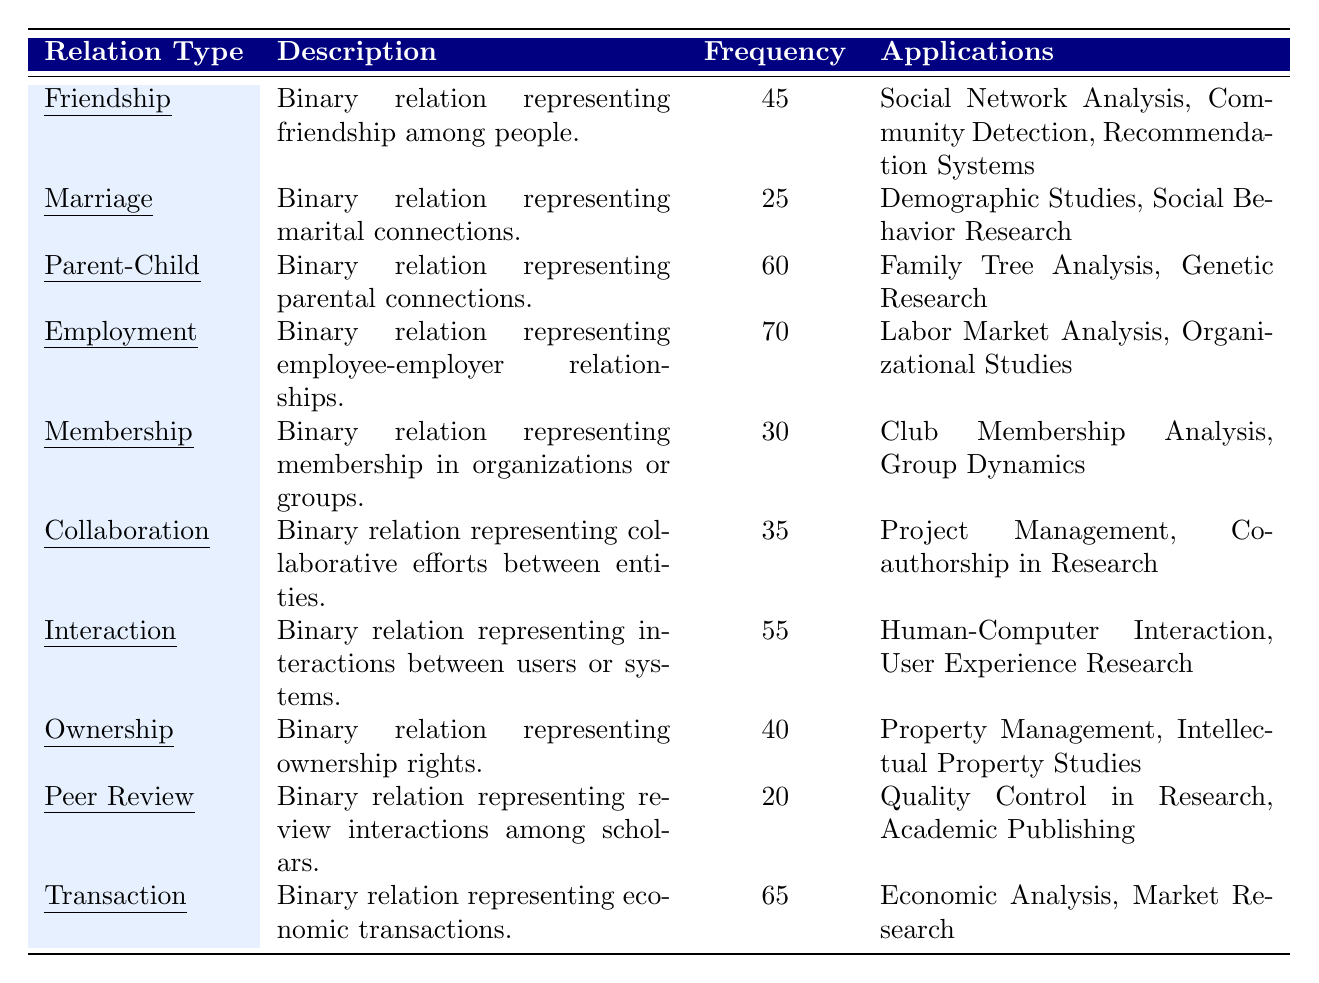What is the frequency of the "Employment" relation type? The table directly lists the frequency of the "Employment" relation type as 70.
Answer: 70 Which relation type has the highest frequency? By checking the frequency column, the relation type with the highest frequency is "Employment," which has a frequency of 70.
Answer: Employment What is the total frequency of all the relation types listed? Adding the frequencies: 45 + 25 + 60 + 70 + 30 + 35 + 55 + 40 + 20 + 65 =  75 + 30 + 95 + 30 + 20 = 355.
Answer: 355 Are there more applications listed for "Parent-Child" than for "Peer Review"? "Parent-Child" has 2 applications listed, while "Peer Review" has 2 applications. This makes them equal, so the answer is no.
Answer: No What is the average frequency of the relation types presented in the table? The total frequency is 355, and there are 10 relation types. The average is 355 / 10 = 35.5.
Answer: 35.5 Which relation type's description mentions "social"? The description for the "Friendship" relation type includes the word "social."
Answer: Friendship Is the frequency of "Marriage" greater than or equal to the average frequency? The frequency of "Marriage" is 25 and the average frequency is 35.5, thus 25 < 35.5, making the statement false.
Answer: No What is the difference between the frequency of "Transaction" and "Peer Review"? The frequency of "Transaction" is 65 and "Peer Review" has a frequency of 20. The difference is 65 - 20 = 45.
Answer: 45 Which two relation types have the least frequency? The relation types with the least frequency are "Peer Review" at 20 and "Marriage" at 25.
Answer: Peer Review and Marriage What percentage of the total frequency does "Interaction" represent? The frequency of "Interaction" is 55. To find the percentage, (55 / 355) * 100 ≈ 15.49%.
Answer: 15.49% 